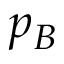<formula> <loc_0><loc_0><loc_500><loc_500>p _ { B }</formula> 